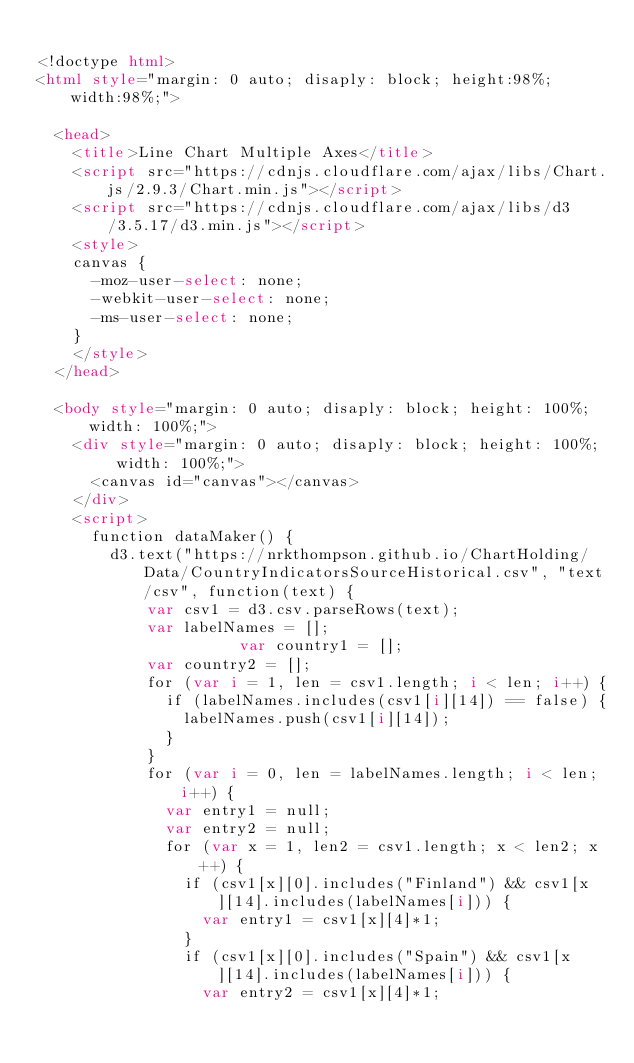<code> <loc_0><loc_0><loc_500><loc_500><_HTML_>
<!doctype html>
<html style="margin: 0 auto; disaply: block; height:98%;  width:98%;">

	<head>
		<title>Line Chart Multiple Axes</title>
		<script src="https://cdnjs.cloudflare.com/ajax/libs/Chart.js/2.9.3/Chart.min.js"></script>
		<script src="https://cdnjs.cloudflare.com/ajax/libs/d3/3.5.17/d3.min.js"></script>
		<style>
		canvas {
			-moz-user-select: none;
			-webkit-user-select: none;
			-ms-user-select: none;
		}
		</style>
	</head>

	<body style="margin: 0 auto; disaply: block; height: 100%;  width: 100%;">
		<div style="margin: 0 auto; disaply: block; height: 100%;  width: 100%;">
			<canvas id="canvas"></canvas>
		</div>
		<script>
			function dataMaker() {
				d3.text("https://nrkthompson.github.io/ChartHolding/Data/CountryIndicatorsSourceHistorical.csv", "text/csv", function(text) {
					  var csv1 = d3.csv.parseRows(text);
					  var labelNames = [];
            				  var country1 = [];
					  var country2 = [];
					  for (var i = 1, len = csv1.length; i < len; i++) {
						  if (labelNames.includes(csv1[i][14]) == false) {
							  labelNames.push(csv1[i][14]);
						  }
					  }
					  for (var i = 0, len = labelNames.length; i < len; i++) {
						  var entry1 = null;
						  var entry2 = null;
						  for (var x = 1, len2 = csv1.length; x < len2; x++) {
							  if (csv1[x][0].includes("Finland") && csv1[x][14].includes(labelNames[i])) {
								  var entry1 = csv1[x][4]*1;
							  }
							  if (csv1[x][0].includes("Spain") && csv1[x][14].includes(labelNames[i])) {
								  var entry2 = csv1[x][4]*1;</code> 